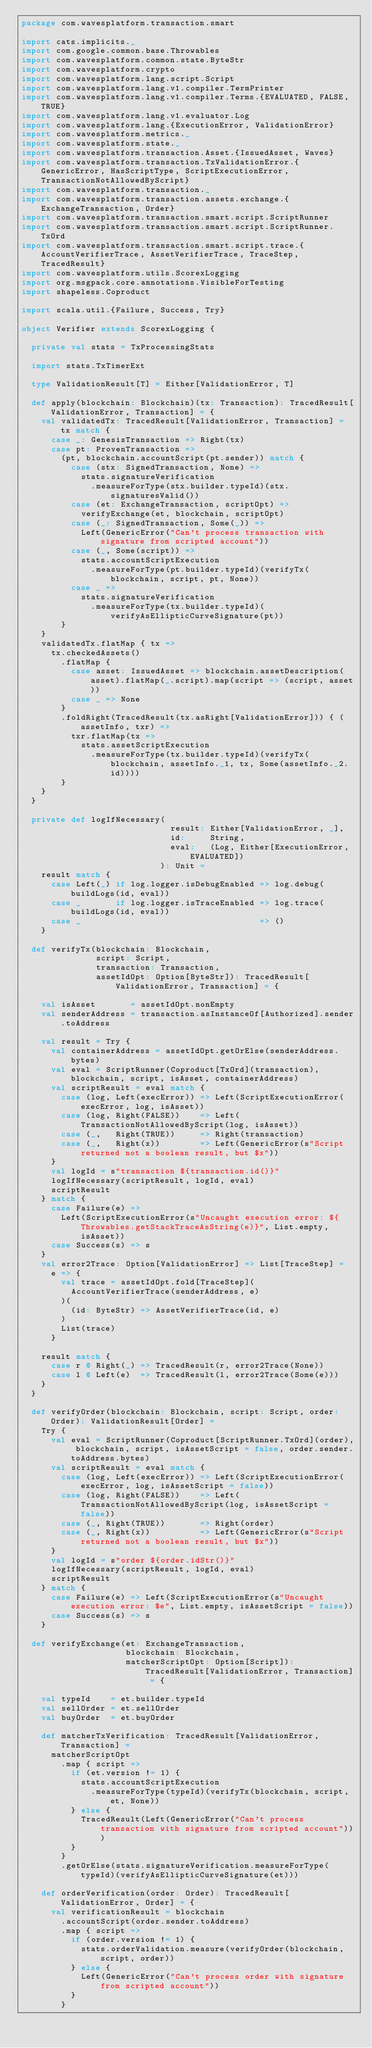Convert code to text. <code><loc_0><loc_0><loc_500><loc_500><_Scala_>package com.wavesplatform.transaction.smart

import cats.implicits._
import com.google.common.base.Throwables
import com.wavesplatform.common.state.ByteStr
import com.wavesplatform.crypto
import com.wavesplatform.lang.script.Script
import com.wavesplatform.lang.v1.compiler.TermPrinter
import com.wavesplatform.lang.v1.compiler.Terms.{EVALUATED, FALSE, TRUE}
import com.wavesplatform.lang.v1.evaluator.Log
import com.wavesplatform.lang.{ExecutionError, ValidationError}
import com.wavesplatform.metrics._
import com.wavesplatform.state._
import com.wavesplatform.transaction.Asset.{IssuedAsset, Waves}
import com.wavesplatform.transaction.TxValidationError.{GenericError, HasScriptType, ScriptExecutionError, TransactionNotAllowedByScript}
import com.wavesplatform.transaction._
import com.wavesplatform.transaction.assets.exchange.{ExchangeTransaction, Order}
import com.wavesplatform.transaction.smart.script.ScriptRunner
import com.wavesplatform.transaction.smart.script.ScriptRunner.TxOrd
import com.wavesplatform.transaction.smart.script.trace.{AccountVerifierTrace, AssetVerifierTrace, TraceStep, TracedResult}
import com.wavesplatform.utils.ScorexLogging
import org.msgpack.core.annotations.VisibleForTesting
import shapeless.Coproduct

import scala.util.{Failure, Success, Try}

object Verifier extends ScorexLogging {

  private val stats = TxProcessingStats

  import stats.TxTimerExt

  type ValidationResult[T] = Either[ValidationError, T]

  def apply(blockchain: Blockchain)(tx: Transaction): TracedResult[ValidationError, Transaction] = {
    val validatedTx: TracedResult[ValidationError, Transaction] = tx match {
      case _: GenesisTransaction => Right(tx)
      case pt: ProvenTransaction =>
        (pt, blockchain.accountScript(pt.sender)) match {
          case (stx: SignedTransaction, None) =>
            stats.signatureVerification
              .measureForType(stx.builder.typeId)(stx.signaturesValid())
          case (et: ExchangeTransaction, scriptOpt) =>
            verifyExchange(et, blockchain, scriptOpt)
          case (_: SignedTransaction, Some(_)) =>
            Left(GenericError("Can't process transaction with signature from scripted account"))
          case (_, Some(script)) =>
            stats.accountScriptExecution
              .measureForType(pt.builder.typeId)(verifyTx(blockchain, script, pt, None))
          case _ =>
            stats.signatureVerification
              .measureForType(tx.builder.typeId)(verifyAsEllipticCurveSignature(pt))
        }
    }
    validatedTx.flatMap { tx =>
      tx.checkedAssets()
        .flatMap {
          case asset: IssuedAsset => blockchain.assetDescription(asset).flatMap(_.script).map(script => (script, asset))
          case _ => None
        }
        .foldRight(TracedResult(tx.asRight[ValidationError])) { (assetInfo, txr) =>
          txr.flatMap(tx =>
            stats.assetScriptExecution
              .measureForType(tx.builder.typeId)(verifyTx(blockchain, assetInfo._1, tx, Some(assetInfo._2.id))))
        }
    }
  }

  private def logIfNecessary(
                              result: Either[ValidationError, _],
                              id:     String,
                              eval:   (Log, Either[ExecutionError, EVALUATED])
                            ): Unit =
    result match {
      case Left(_) if log.logger.isDebugEnabled => log.debug(buildLogs(id, eval))
      case _       if log.logger.isTraceEnabled => log.trace(buildLogs(id, eval))
      case _                                    => ()
    }

  def verifyTx(blockchain: Blockchain,
               script: Script,
               transaction: Transaction,
               assetIdOpt: Option[ByteStr]): TracedResult[ValidationError, Transaction] = {

    val isAsset       = assetIdOpt.nonEmpty
    val senderAddress = transaction.asInstanceOf[Authorized].sender.toAddress

    val result = Try {
      val containerAddress = assetIdOpt.getOrElse(senderAddress.bytes)
      val eval = ScriptRunner(Coproduct[TxOrd](transaction), blockchain, script, isAsset, containerAddress)
      val scriptResult = eval match {
        case (log, Left(execError)) => Left(ScriptExecutionError(execError, log, isAsset))
        case (log, Right(FALSE))    => Left(TransactionNotAllowedByScript(log, isAsset))
        case (_,   Right(TRUE))     => Right(transaction)
        case (_,   Right(x))        => Left(GenericError(s"Script returned not a boolean result, but $x"))
      }
      val logId = s"transaction ${transaction.id()}"
      logIfNecessary(scriptResult, logId, eval)
      scriptResult
    } match {
      case Failure(e) =>
        Left(ScriptExecutionError(s"Uncaught execution error: ${Throwables.getStackTraceAsString(e)}", List.empty, isAsset))
      case Success(s) => s
    }
    val error2Trace: Option[ValidationError] => List[TraceStep] =
      e => {
        val trace = assetIdOpt.fold[TraceStep](
          AccountVerifierTrace(senderAddress, e)
        )(
          (id: ByteStr) => AssetVerifierTrace(id, e)
        )
        List(trace)
      }

    result match {
      case r @ Right(_) => TracedResult(r, error2Trace(None))
      case l @ Left(e)  => TracedResult(l, error2Trace(Some(e)))
    }
  }

  def verifyOrder(blockchain: Blockchain, script: Script, order: Order): ValidationResult[Order] =
    Try {
      val eval = ScriptRunner(Coproduct[ScriptRunner.TxOrd](order), blockchain, script, isAssetScript = false, order.sender.toAddress.bytes)
      val scriptResult = eval match {
        case (log, Left(execError)) => Left(ScriptExecutionError(execError, log, isAssetScript = false))
        case (log, Right(FALSE))    => Left(TransactionNotAllowedByScript(log, isAssetScript = false))
        case (_, Right(TRUE))       => Right(order)
        case (_, Right(x))          => Left(GenericError(s"Script returned not a boolean result, but $x"))
      }
      val logId = s"order ${order.idStr()}"
      logIfNecessary(scriptResult, logId, eval)
      scriptResult
    } match {
      case Failure(e) => Left(ScriptExecutionError(s"Uncaught execution error: $e", List.empty, isAssetScript = false))
      case Success(s) => s
    }

  def verifyExchange(et: ExchangeTransaction,
                     blockchain: Blockchain,
                     matcherScriptOpt: Option[Script]): TracedResult[ValidationError, Transaction] = {

    val typeId    = et.builder.typeId
    val sellOrder = et.sellOrder
    val buyOrder  = et.buyOrder

    def matcherTxVerification: TracedResult[ValidationError, Transaction] =
      matcherScriptOpt
        .map { script =>
          if (et.version != 1) {
            stats.accountScriptExecution
              .measureForType(typeId)(verifyTx(blockchain, script, et, None))
          } else {
            TracedResult(Left(GenericError("Can't process transaction with signature from scripted account")))
          }
        }
        .getOrElse(stats.signatureVerification.measureForType(typeId)(verifyAsEllipticCurveSignature(et)))

    def orderVerification(order: Order): TracedResult[ValidationError, Order] = {
      val verificationResult = blockchain
        .accountScript(order.sender.toAddress)
        .map { script =>
          if (order.version != 1) {
            stats.orderValidation.measure(verifyOrder(blockchain, script, order))
          } else {
            Left(GenericError("Can't process order with signature from scripted account"))
          }
        }</code> 